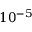<formula> <loc_0><loc_0><loc_500><loc_500>1 0 ^ { - 5 }</formula> 